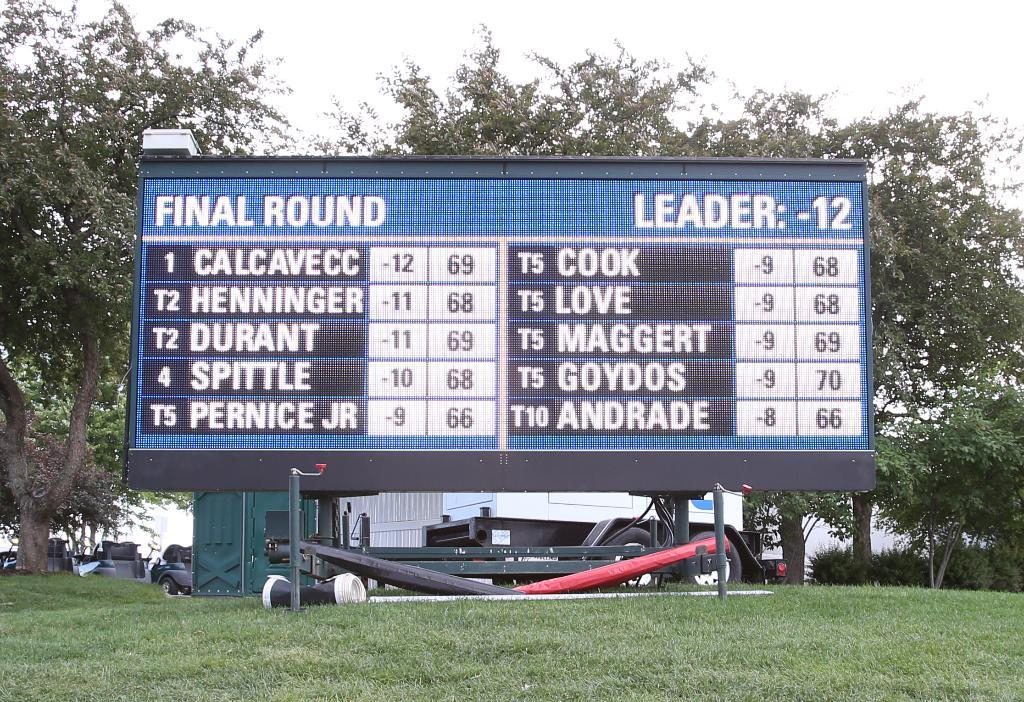<image>
Describe the image concisely. A large sign lists the leaders and scores of the final round. 